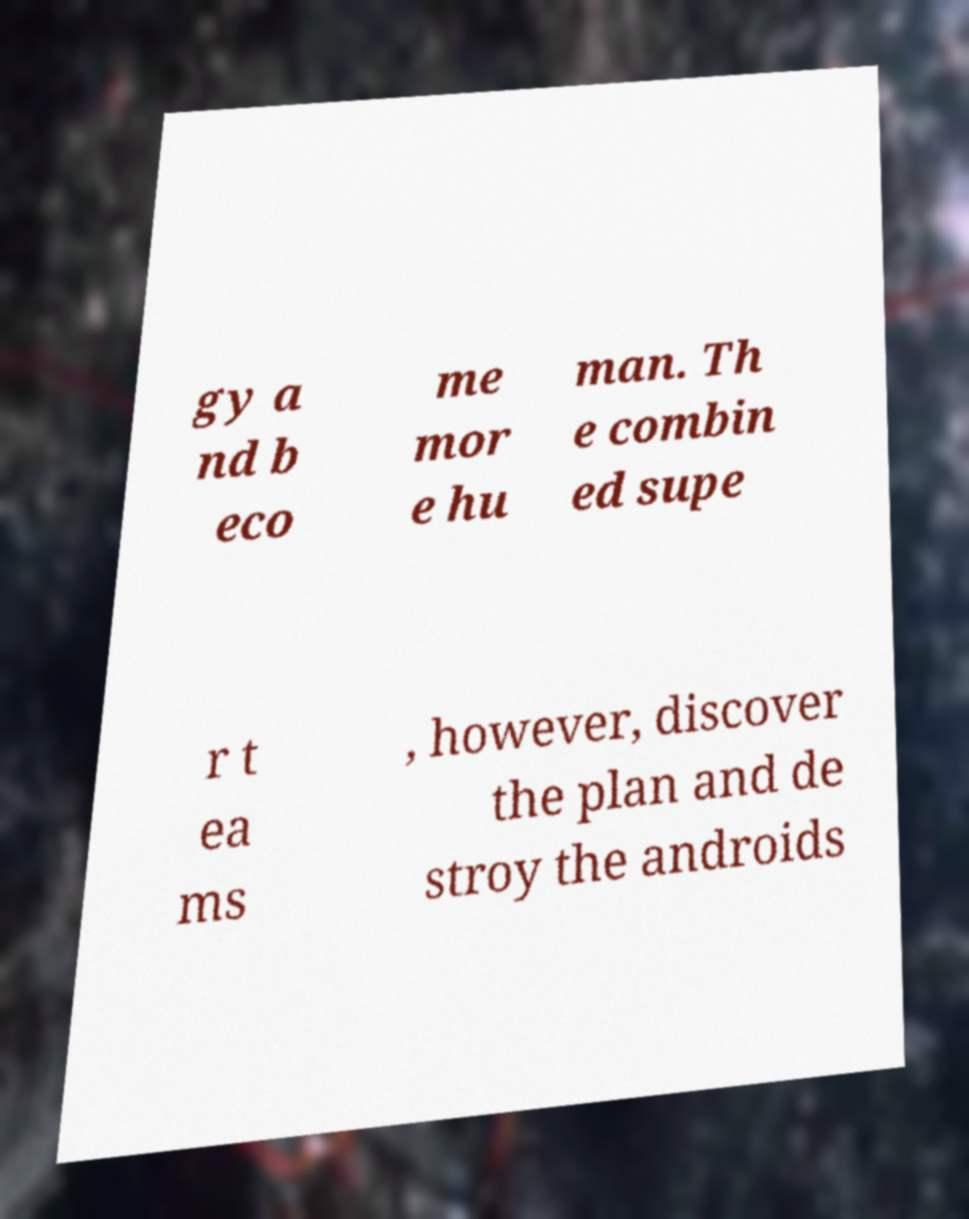Can you read and provide the text displayed in the image?This photo seems to have some interesting text. Can you extract and type it out for me? gy a nd b eco me mor e hu man. Th e combin ed supe r t ea ms , however, discover the plan and de stroy the androids 